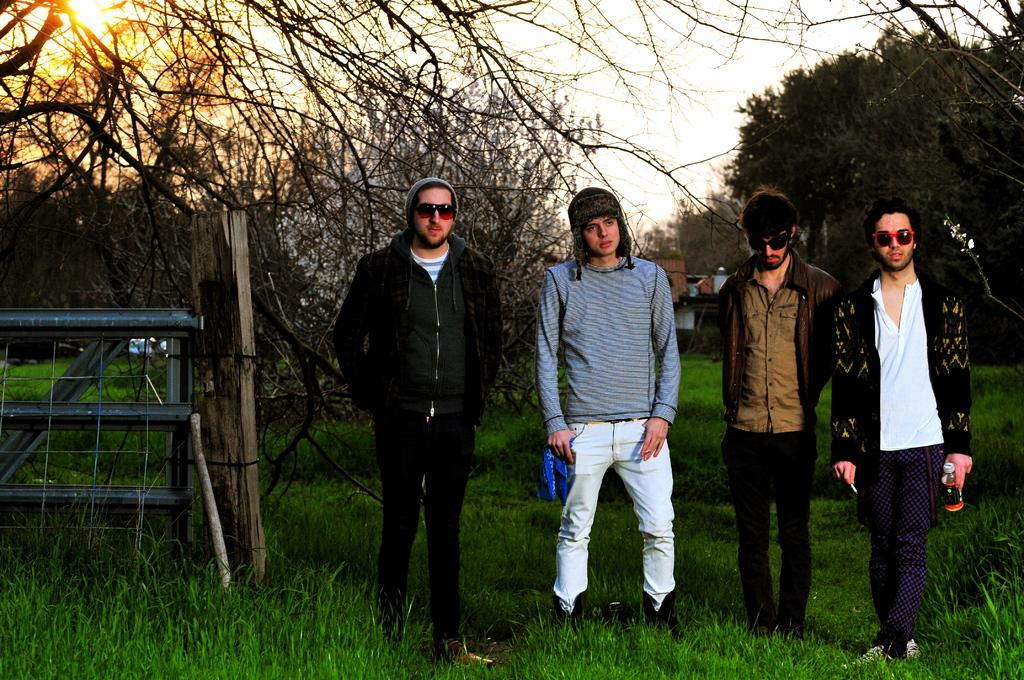How many people are in the image? There are four persons in the image. What is the ground like where the persons are standing? The persons are standing on a greenery ground. What can be seen in the background of the image? There are trees in the background of the image. What type of bridge is visible in the image? There is no bridge present in the image. What government policies are being discussed by the persons in the image? There is no indication in the image that the persons are discussing government policies or any specific topic. 